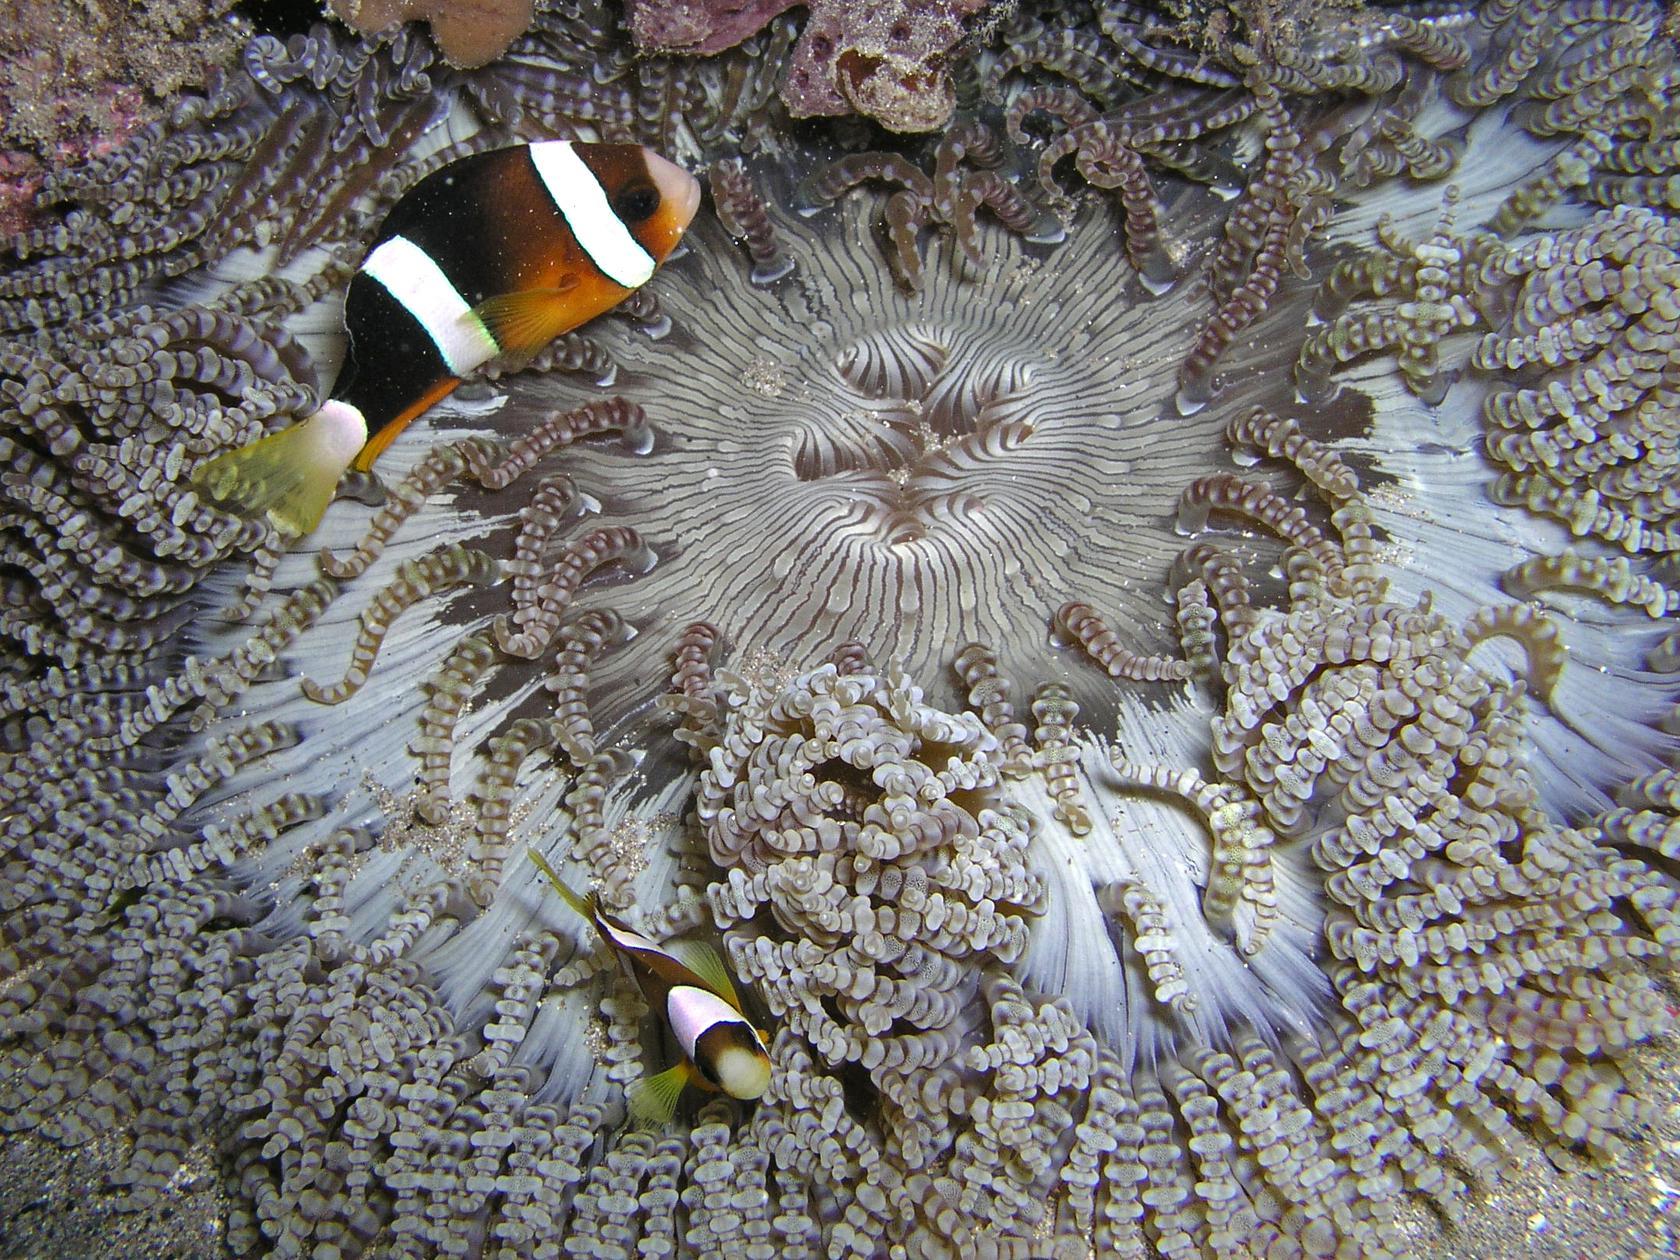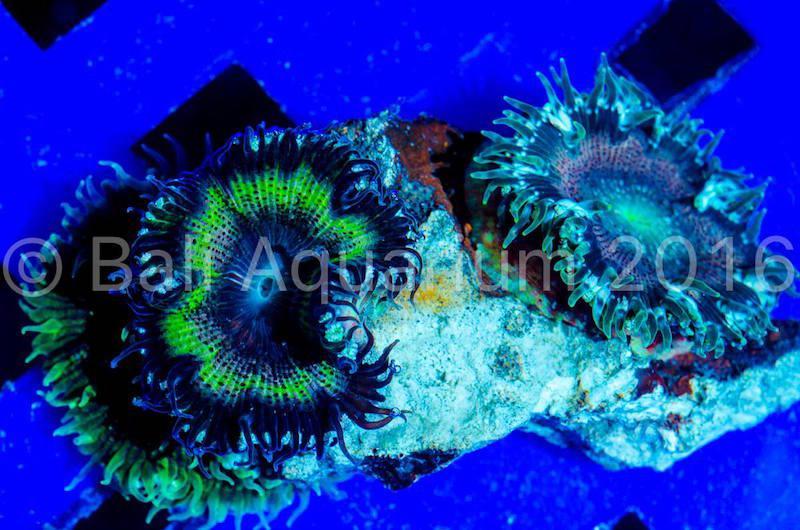The first image is the image on the left, the second image is the image on the right. Given the left and right images, does the statement "There are at least two clown fish." hold true? Answer yes or no. Yes. The first image is the image on the left, the second image is the image on the right. For the images displayed, is the sentence "Right image features an anemone with stringy whitish tendrils, and the left image includes a pale white anemone." factually correct? Answer yes or no. No. 